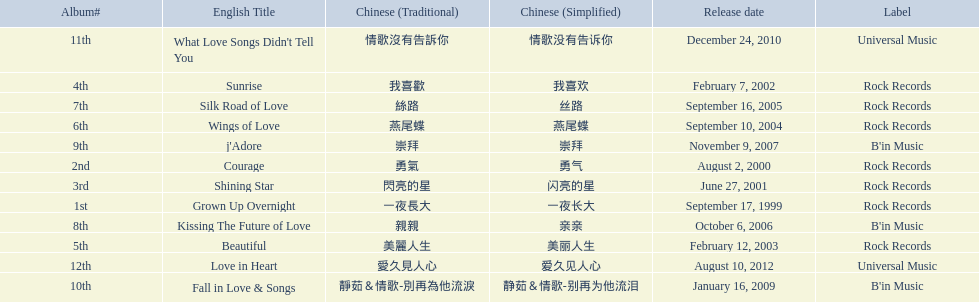What were the albums? Grown Up Overnight, Courage, Shining Star, Sunrise, Beautiful, Wings of Love, Silk Road of Love, Kissing The Future of Love, j'Adore, Fall in Love & Songs, What Love Songs Didn't Tell You, Love in Heart. Which ones were released by b'in music? Kissing The Future of Love, j'Adore. Of these, which one was in an even-numbered year? Kissing The Future of Love. 